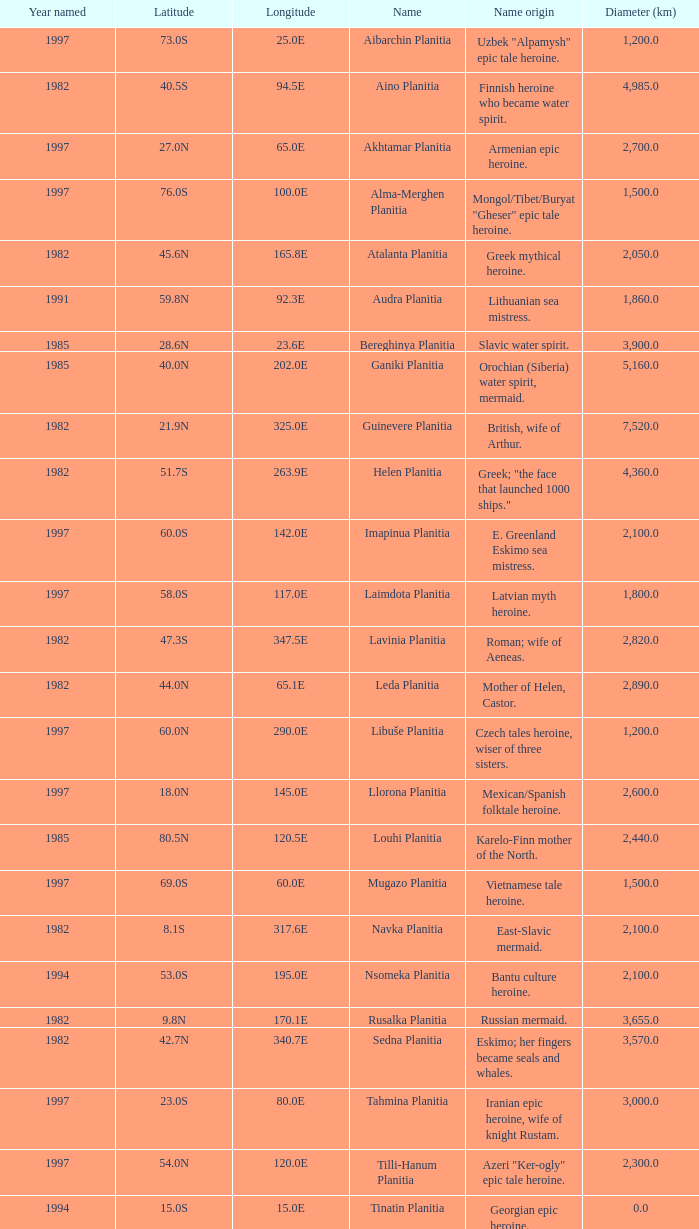What is the diameter (km) of feature of latitude 40.5s 4985.0. 